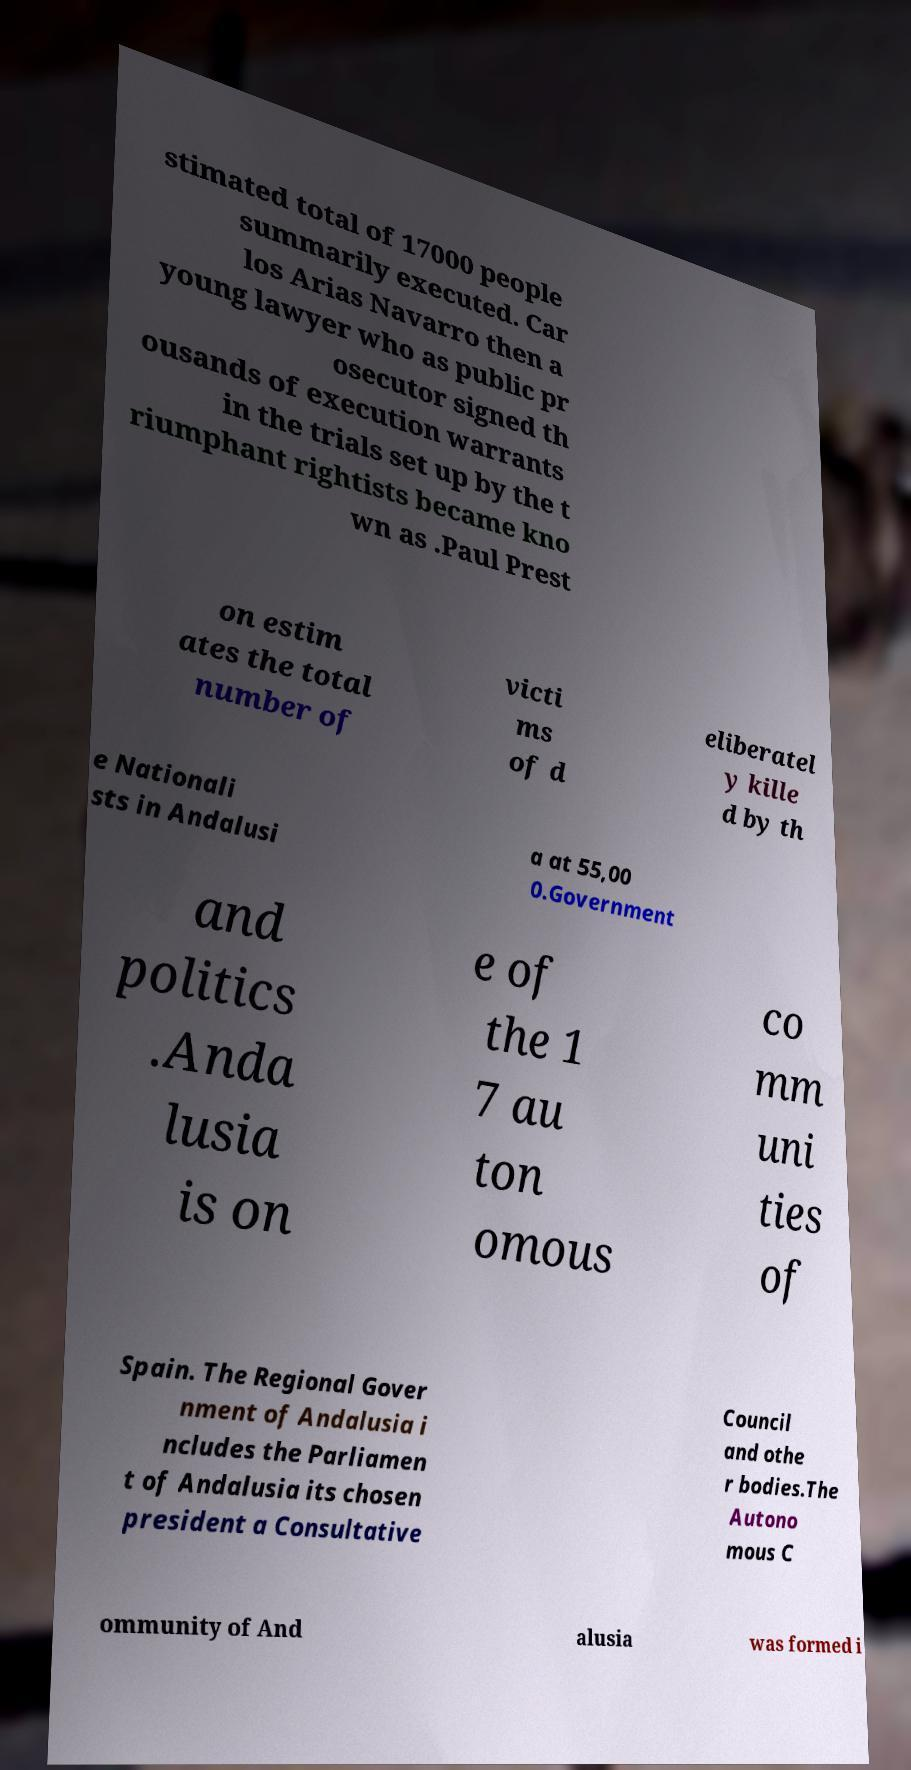Could you extract and type out the text from this image? stimated total of 17000 people summarily executed. Car los Arias Navarro then a young lawyer who as public pr osecutor signed th ousands of execution warrants in the trials set up by the t riumphant rightists became kno wn as .Paul Prest on estim ates the total number of victi ms of d eliberatel y kille d by th e Nationali sts in Andalusi a at 55,00 0.Government and politics .Anda lusia is on e of the 1 7 au ton omous co mm uni ties of Spain. The Regional Gover nment of Andalusia i ncludes the Parliamen t of Andalusia its chosen president a Consultative Council and othe r bodies.The Autono mous C ommunity of And alusia was formed i 